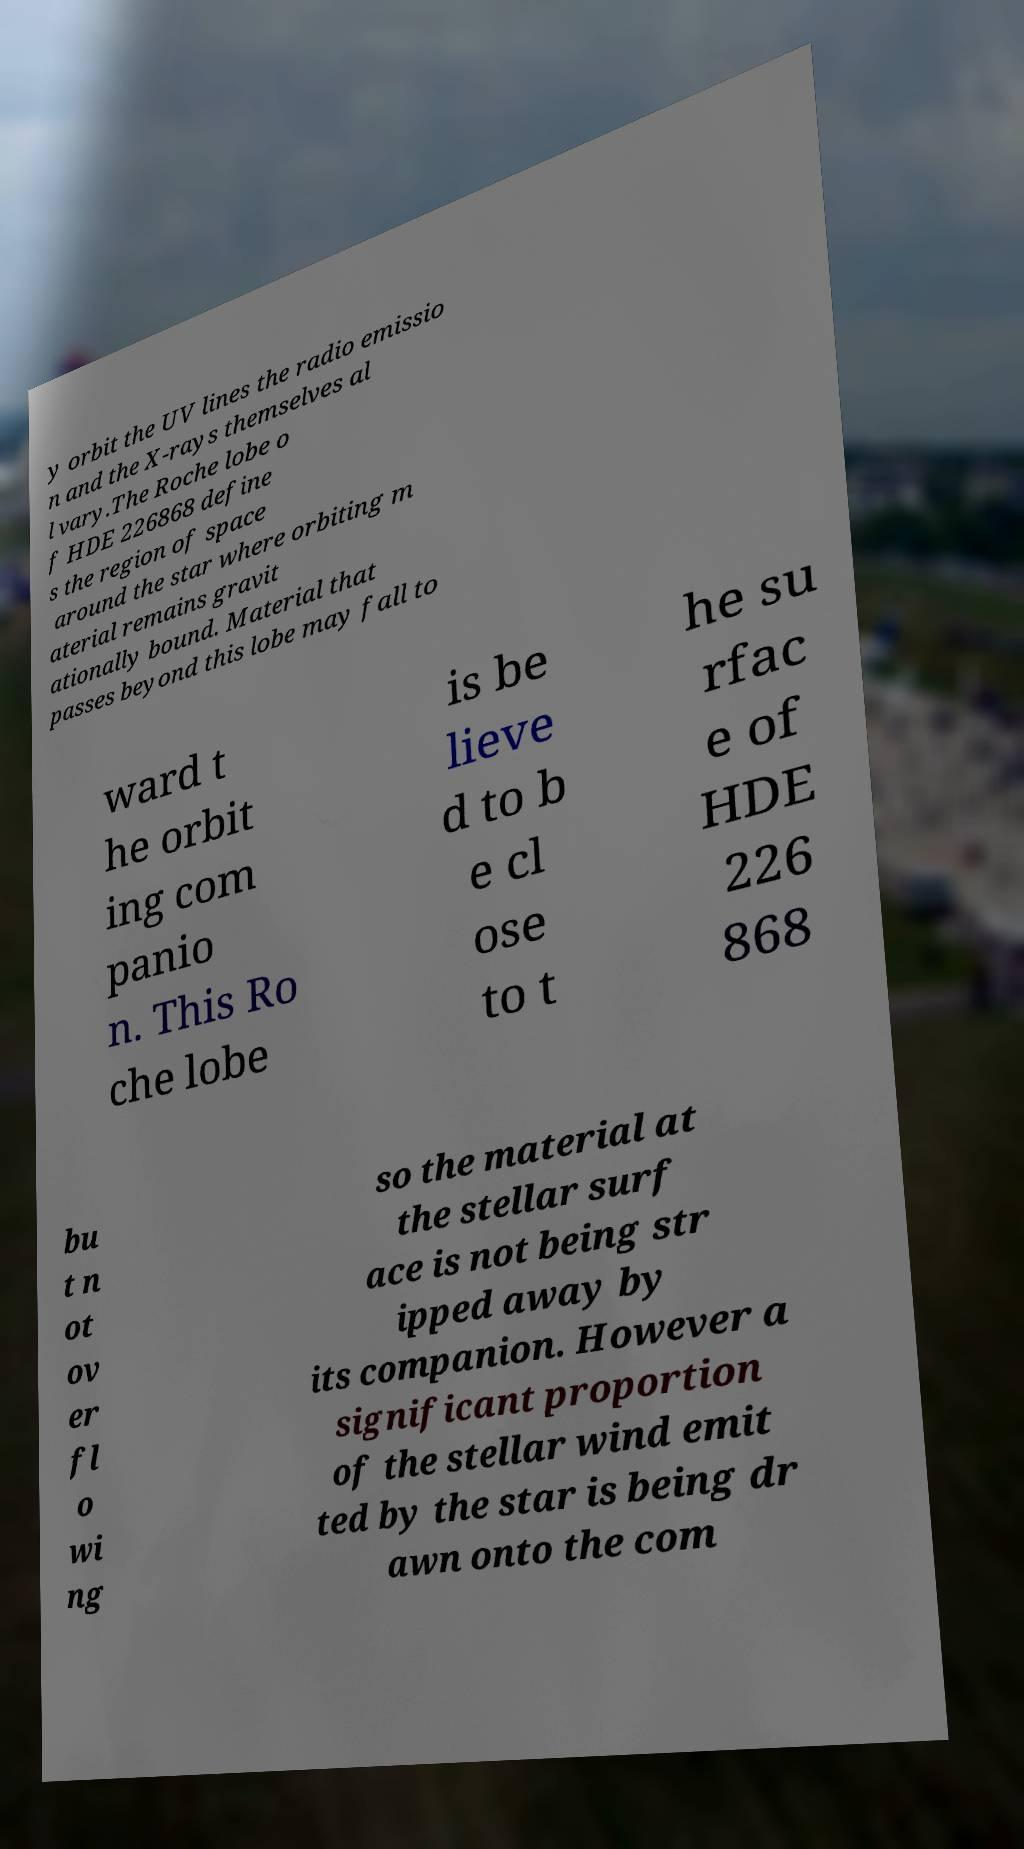Could you assist in decoding the text presented in this image and type it out clearly? y orbit the UV lines the radio emissio n and the X-rays themselves al l vary.The Roche lobe o f HDE 226868 define s the region of space around the star where orbiting m aterial remains gravit ationally bound. Material that passes beyond this lobe may fall to ward t he orbit ing com panio n. This Ro che lobe is be lieve d to b e cl ose to t he su rfac e of HDE 226 868 bu t n ot ov er fl o wi ng so the material at the stellar surf ace is not being str ipped away by its companion. However a significant proportion of the stellar wind emit ted by the star is being dr awn onto the com 